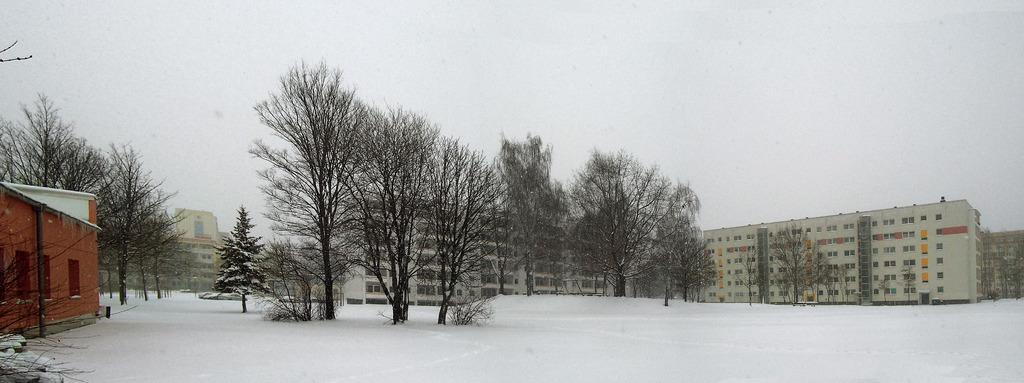What type of vegetation can be seen in the image? There are trees in the image. What type of structures are present in the image? There are buildings in the image. What is the weather like in the image? There is snow visible in the image, indicating a cold or wintry environment. What is visible in the background of the image? The sky is visible in the image. Can you see any locks on the trees in the image? There are no locks visible on the trees in the image. What color is the hair of the person in the image? There is no person present in the image, so hair color cannot be determined. 